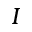<formula> <loc_0><loc_0><loc_500><loc_500>I</formula> 